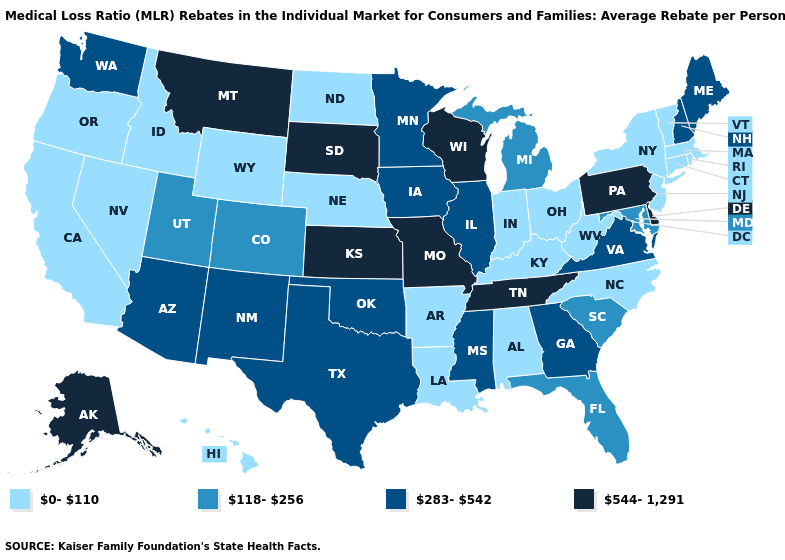Among the states that border Louisiana , does Mississippi have the highest value?
Short answer required. Yes. What is the value of New York?
Quick response, please. 0-110. How many symbols are there in the legend?
Write a very short answer. 4. Does Michigan have the highest value in the USA?
Keep it brief. No. Which states have the lowest value in the MidWest?
Short answer required. Indiana, Nebraska, North Dakota, Ohio. Which states hav the highest value in the West?
Concise answer only. Alaska, Montana. What is the lowest value in the South?
Be succinct. 0-110. What is the value of Missouri?
Short answer required. 544-1,291. What is the value of Louisiana?
Be succinct. 0-110. Among the states that border Wisconsin , which have the highest value?
Concise answer only. Illinois, Iowa, Minnesota. Name the states that have a value in the range 544-1,291?
Write a very short answer. Alaska, Delaware, Kansas, Missouri, Montana, Pennsylvania, South Dakota, Tennessee, Wisconsin. What is the value of Alaska?
Quick response, please. 544-1,291. Does Ohio have the lowest value in the MidWest?
Give a very brief answer. Yes. What is the lowest value in the USA?
Give a very brief answer. 0-110. 